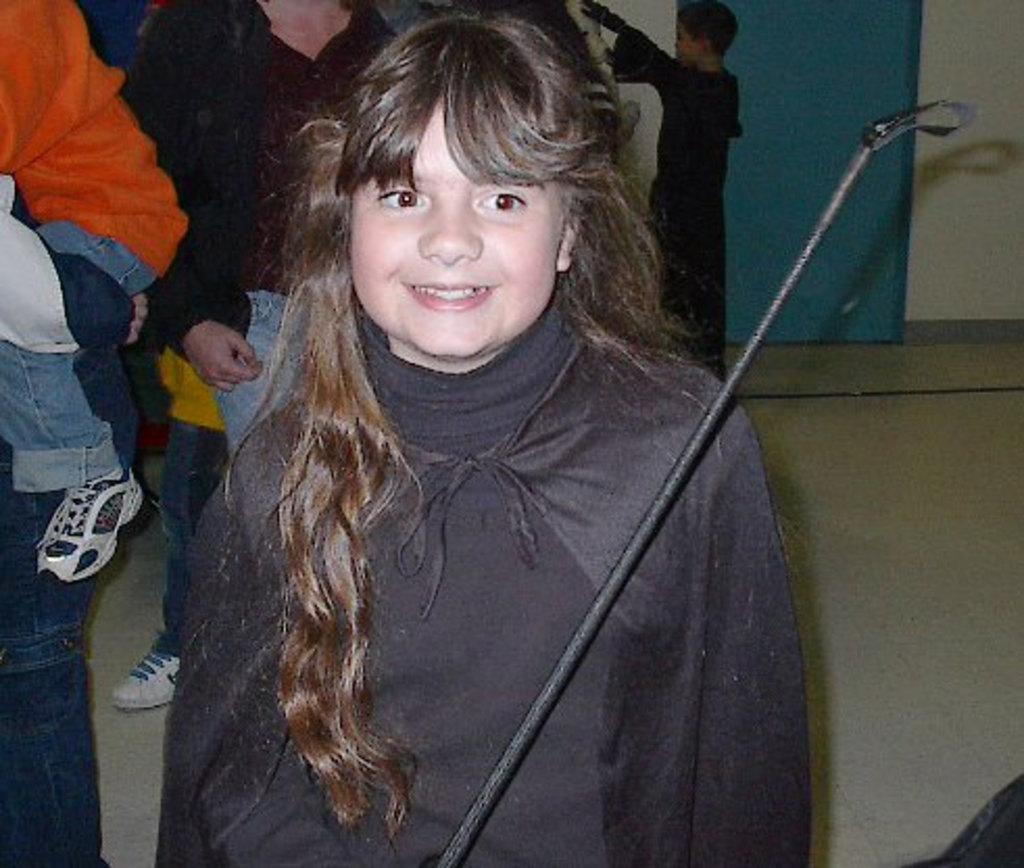Who is the main subject in the image? There is a girl in the image. What is the girl wearing? The girl is wearing a black dress. What object is in front of the girl? There is a black rod in front of the girl. What can be seen in the background of the image? There are many people in the background of the image. What type of cheese is being used to create the things in the image? There is no cheese present in the image, and no objects are being created. 